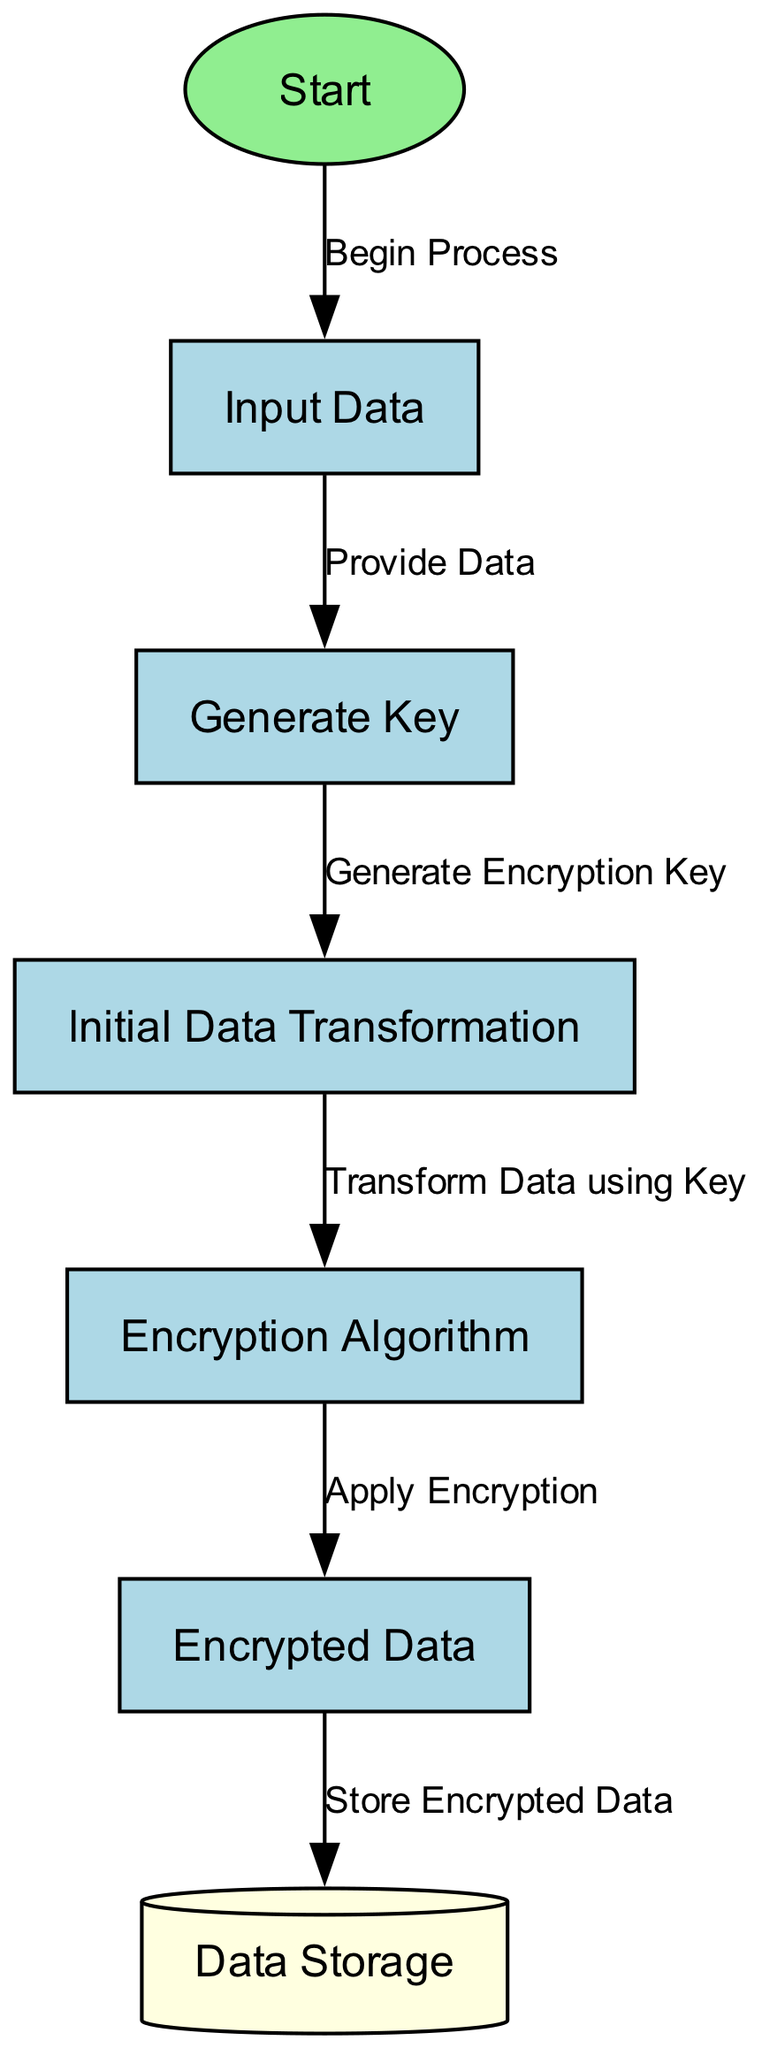What is the starting point of the process? The diagram indicates that the starting point of the process is labeled as "Start", which is the first node in the sequence.
Answer: Start How many nodes are in the workflow? The diagram shows a total of seven nodes representing different steps in the data encryption workflow from start to storage.
Answer: Seven What is the label of the node connected to "Input Data"? The node that follows "Input Data" is labeled "Generate Key", which indicates the step taken after providing the input data.
Answer: Generate Key Which node is responsible for applying the encryption? The node labeled "Apply Encryption" carries out the encryption of the data, representing the main action of the encryption algorithm.
Answer: Encryption Algorithm What type of node is "Data Storage"? In the diagram, "Data Storage" is represented as a cylinder, which is a specific shape used to depict storage in flowcharts and diagrams.
Answer: Cylinder What is the relationship between "Generate Key" and "Initial Data Transformation"? The edge connecting "Generate Key" to "Initial Data Transformation" indicates that generating the encryption key is a prerequisite step before any data transformation occurs.
Answer: Generate Encryption Key What is the output of the workflow? The final output of the workflow is represented in the node labeled "Encrypted Data", which signifies the product of the encryption process.
Answer: Encrypted Data How many edges are leading to "Store Encrypted Data"? There is one edge leading to "Store Encrypted Data", which connects it from the "Encrypted Data" node, depicting the flow of data storage.
Answer: One Which node comes before "Encrypted Data"? The node that comes immediately before "Encrypted Data" is labeled "Encryption Algorithm", which indicates that encryption must occur before the data can be considered in its encrypted form.
Answer: Encryption Algorithm 